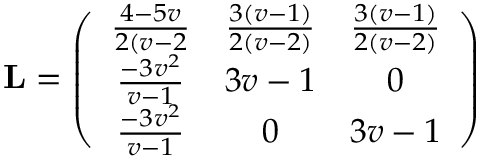Convert formula to latex. <formula><loc_0><loc_0><loc_500><loc_500>L = \left ( \begin{array} { c c c } { \frac { 4 - 5 v } { 2 ( v - 2 } } & { \frac { 3 ( v - 1 ) } { 2 ( v - 2 ) } } & { \frac { 3 ( v - 1 ) } { 2 ( v - 2 ) } } \\ { \frac { - 3 v ^ { 2 } } { v - 1 } } & { 3 v - 1 } & { 0 } \\ { \frac { - 3 v ^ { 2 } } { v - 1 } } & { 0 } & { 3 v - 1 } \end{array} \right )</formula> 